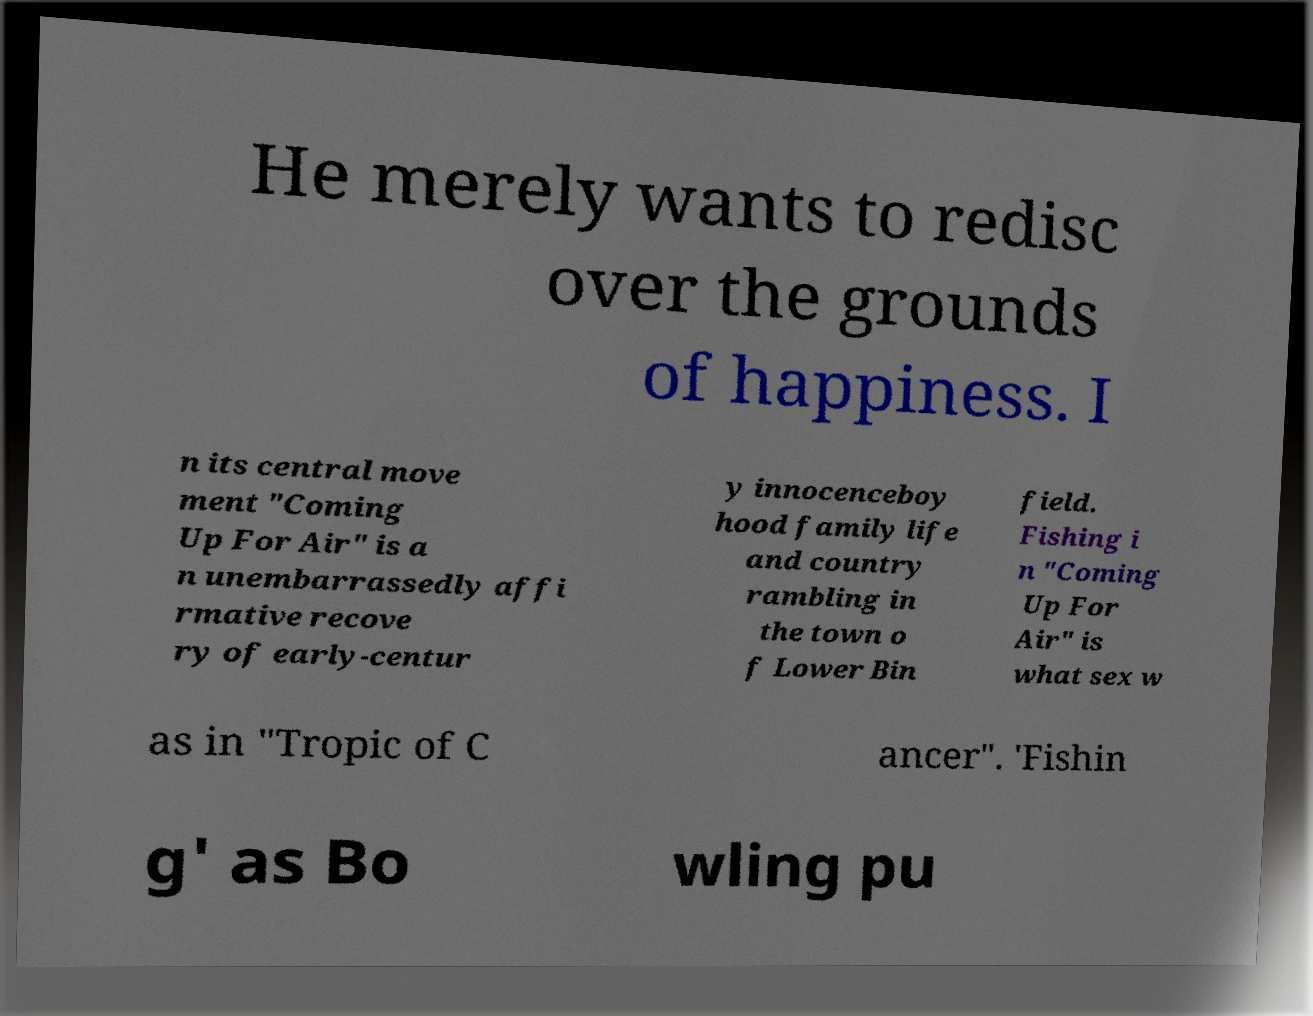What messages or text are displayed in this image? I need them in a readable, typed format. He merely wants to redisc over the grounds of happiness. I n its central move ment "Coming Up For Air" is a n unembarrassedly affi rmative recove ry of early-centur y innocenceboy hood family life and country rambling in the town o f Lower Bin field. Fishing i n "Coming Up For Air" is what sex w as in "Tropic of C ancer". 'Fishin g' as Bo wling pu 